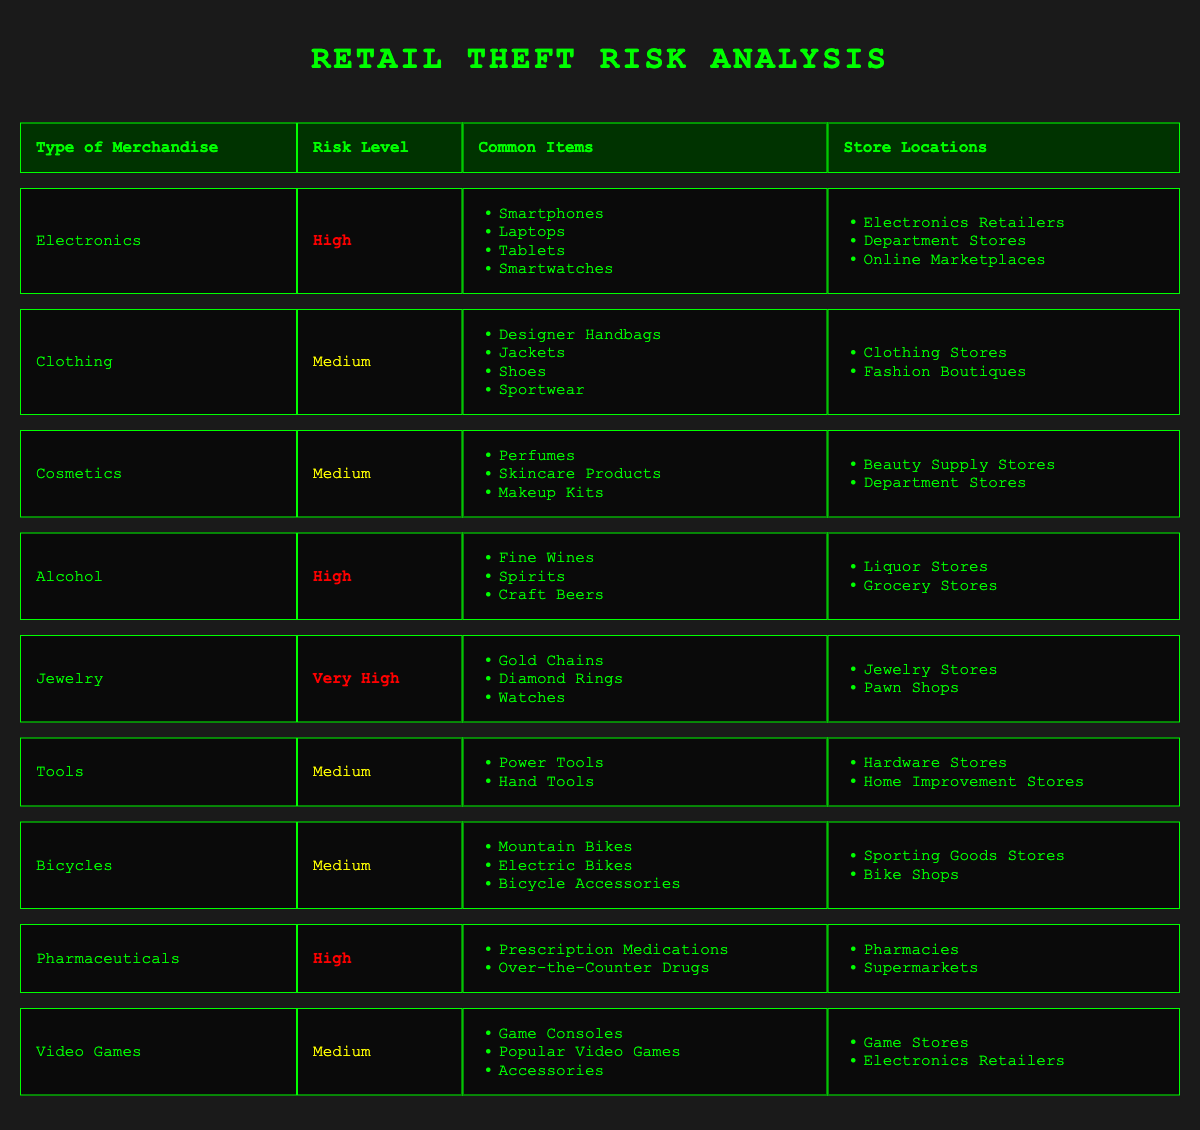What type of merchandise has the highest risk level? By examining the risk levels listed in the table, it is noted that "Jewelry" has a risk level of "Very High," which is higher than any other merchandise type.
Answer: Jewelry Which common items are included in the "Electronics" category? The table lists several common items under "Electronics," which include Smartphones, Laptops, Tablets, and Smartwatches.
Answer: Smartphones, Laptops, Tablets, Smartwatches How many types of merchandise have a "Medium" risk level? By reviewing the risk level column, we count the entries marked as "Medium." The types with a medium risk level are Clothing, Cosmetics, Tools, Bicycles, and Video Games, totaling five types.
Answer: 5 Is "Alcohol" considered a high-risk merchandise type? The table shows that "Alcohol" has a risk level of "High," confirming that it is indeed considered high-risk.
Answer: Yes Which store locations are associated with "Pharmaceuticals"? The table indicates that "Pharmaceuticals" can be found in Pharmacies and Supermarkets as its associated store locations.
Answer: Pharmacies, Supermarkets What are the common items for the "Jewelry" category? According to the table, the common items listed under "Jewelry" include Gold Chains, Diamond Rings, and Watches.
Answer: Gold Chains, Diamond Rings, Watches Which merchandise type has fewer common items: "Bicycles" or "Cosmetics"? The "Bicycles" category lists three common items while "Cosmetics" lists three as well. Therefore, both have the same count of common items, leading to the conclusion that neither has fewer than the other.
Answer: Neither Combine the risk levels of "Tools" and "Clothing." What is the combined risk? The risk level for "Tools" is "Medium," and for "Clothing," it's also "Medium." When processed logically, combining two medium risk levels retains a "Medium" status overall.
Answer: Medium Does "Video Games" have a higher risk level than "Bicycles"? Upon comparison of the risk levels marked in the table, both "Video Games" and "Bicycles" have a risk level of "Medium," which indicates that neither has a higher risk level than the other.
Answer: No 